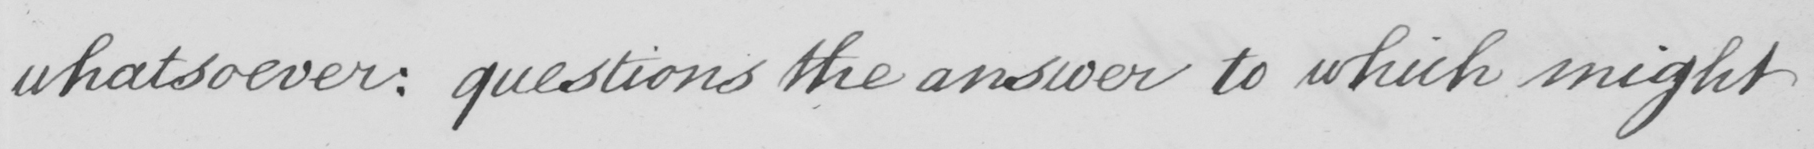What does this handwritten line say? whatsoever :  questions the answer to which might 